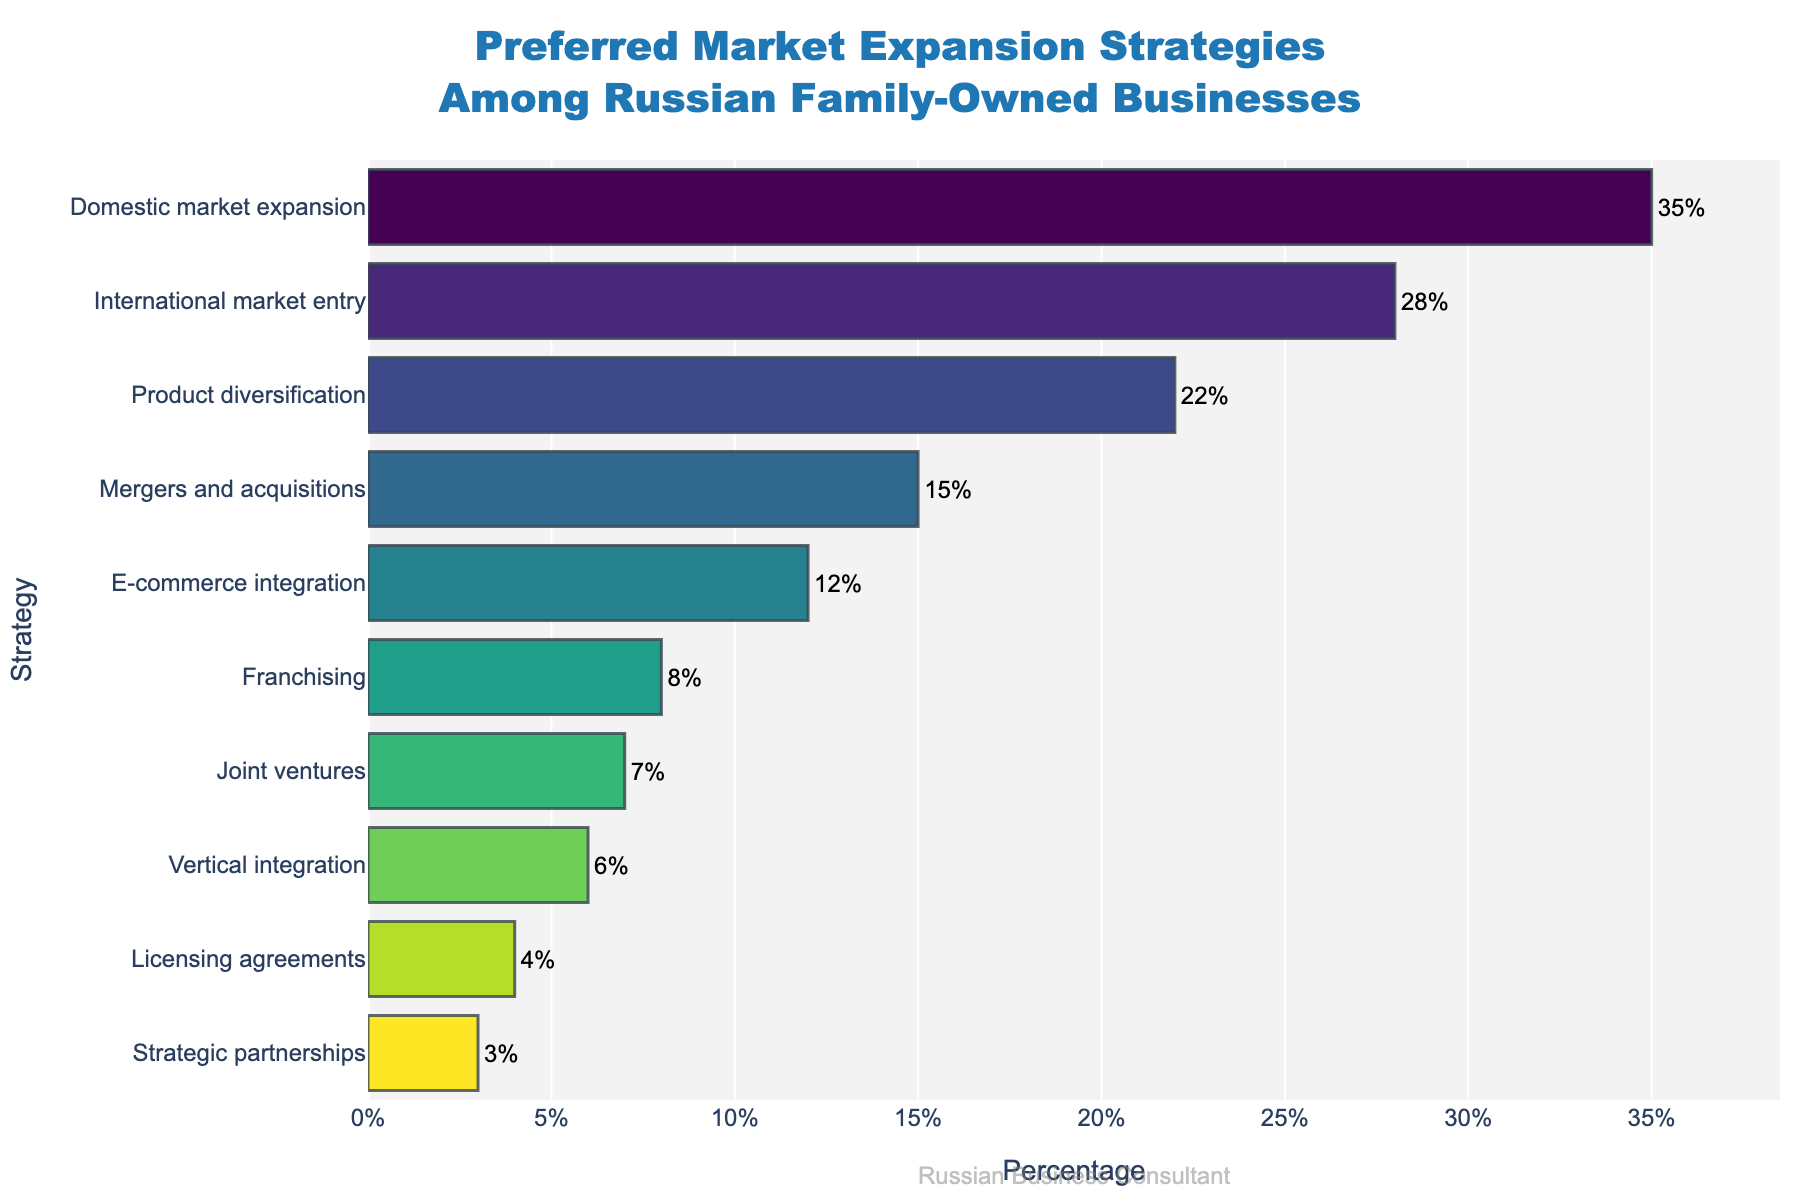Which strategy has the highest percentage? Look for the bar with the greatest length and percentage value. "Domestic market expansion" is the longest bar with the highest percentage of 35%.
Answer: Domestic market expansion Which strategies have a percentage less than 10%? Identify the bars with lengths corresponding to percentages below 10%. They are "Franchising" (8%), "Joint ventures" (7%), "Vertical integration" (6%), "Licensing agreements" (4%), and "Strategic partnerships" (3%).
Answer: Franchising, Joint ventures, Vertical integration, Licensing agreements, Strategic partnerships What is the sum of the percentages for the top three strategies? Sum the percentages of the top three bars: "Domestic market expansion" (35%), "International market entry" (28%), and "Product diversification" (22%). 35 + 28 + 22 = 85.
Answer: 85 Which strategy is preferred more: E-commerce integration or Franchising? Compare the length of the bars for "E-commerce integration" and "Franchising". "E-commerce integration" has a percentage of 12%, which is greater than "Franchising" at 8%.
Answer: E-commerce integration For the strategies with percentages above 20%, what is the average percentage? Identify strategies above 20%: "Domestic market expansion" (35%), "International market entry" (28%), and "Product diversification" (22%). Calculate the average: (35 + 28 + 22) / 3 = 28.33.
Answer: 28.33 How much greater is the percentage of Product diversification compared to Vertical integration? Subtract the percentage of "Vertical integration" (6%) from "Product diversification" (22%). 22 - 6 = 16.
Answer: 16 Which has a higher percentage: Mergers and acquisitions or Joint ventures? Compare the lengths of the bars for "Mergers and acquisitions" and "Joint ventures". "Mergers and acquisitions" has a higher percentage of 15% versus 7% for "Joint ventures".
Answer: Mergers and acquisitions What is the second least preferred strategy? Identify the second shortest bar, which represents "Licensing agreements" with a percentage of 4%.
Answer: Licensing agreements What is the difference in percentage between the most and least preferred strategies? Subtract the percentage of the least preferred strategy "Strategic partnerships" (3%) from the most preferred strategy "Domestic market expansion" (35%). 35 - 3 = 32.
Answer: 32 